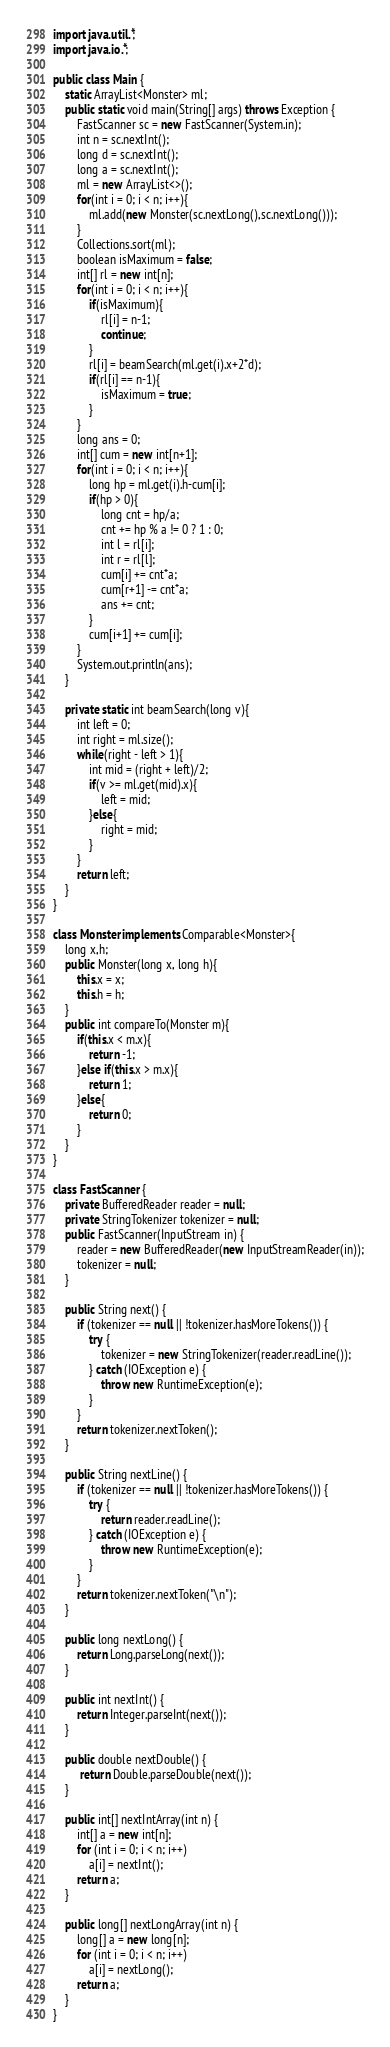<code> <loc_0><loc_0><loc_500><loc_500><_Java_>import java.util.*;
import java.io.*;
 
public class Main {
    static ArrayList<Monster> ml;
    public static void main(String[] args) throws Exception {
        FastScanner sc = new FastScanner(System.in);
        int n = sc.nextInt();
        long d = sc.nextInt();
        long a = sc.nextInt();
        ml = new ArrayList<>();
        for(int i = 0; i < n; i++){
            ml.add(new Monster(sc.nextLong(),sc.nextLong()));
        }
        Collections.sort(ml);
        boolean isMaximum = false;
        int[] rl = new int[n];
        for(int i = 0; i < n; i++){
            if(isMaximum){
                rl[i] = n-1;
                continue;
            }
            rl[i] = beamSearch(ml.get(i).x+2*d);
            if(rl[i] == n-1){
                isMaximum = true;
            }
        }
        long ans = 0;
        int[] cum = new int[n+1];
        for(int i = 0; i < n; i++){
            long hp = ml.get(i).h-cum[i];
            if(hp > 0){
                long cnt = hp/a;
                cnt += hp % a != 0 ? 1 : 0;
                int l = rl[i];
                int r = rl[l];
                cum[i] += cnt*a;
                cum[r+1] -= cnt*a;
                ans += cnt;
            }
            cum[i+1] += cum[i];
        }
        System.out.println(ans);
    }
    
    private static int beamSearch(long v){
        int left = 0;
        int right = ml.size();
        while(right - left > 1){
            int mid = (right + left)/2;
            if(v >= ml.get(mid).x){
                left = mid;
            }else{
                right = mid;
            }
        }
        return left;
    }
}

class Monster implements Comparable<Monster>{
    long x,h;
    public Monster(long x, long h){
        this.x = x;
        this.h = h;
    }
    public int compareTo(Monster m){
        if(this.x < m.x){
            return -1;
        }else if(this.x > m.x){
            return 1;
        }else{
            return 0;
        }
    }
}

class FastScanner {
    private BufferedReader reader = null;
    private StringTokenizer tokenizer = null;
    public FastScanner(InputStream in) {
        reader = new BufferedReader(new InputStreamReader(in));
        tokenizer = null;
    }

    public String next() {
        if (tokenizer == null || !tokenizer.hasMoreTokens()) {
            try {
                tokenizer = new StringTokenizer(reader.readLine());
            } catch (IOException e) {
                throw new RuntimeException(e);
            }
        }
        return tokenizer.nextToken();
    }

    public String nextLine() {
        if (tokenizer == null || !tokenizer.hasMoreTokens()) {
            try {
                return reader.readLine();
            } catch (IOException e) {
                throw new RuntimeException(e);
            }
        }
        return tokenizer.nextToken("\n");
    }

    public long nextLong() {
        return Long.parseLong(next());
    }

    public int nextInt() {
        return Integer.parseInt(next());
    }

    public double nextDouble() {
         return Double.parseDouble(next());
    }

    public int[] nextIntArray(int n) {
        int[] a = new int[n];
        for (int i = 0; i < n; i++)
            a[i] = nextInt();
        return a;
    }

    public long[] nextLongArray(int n) {
        long[] a = new long[n];
        for (int i = 0; i < n; i++)
            a[i] = nextLong();
        return a;
    } 
}
</code> 